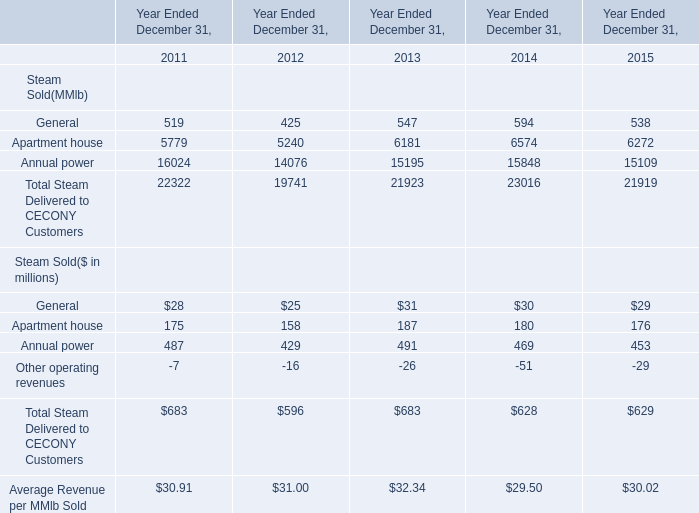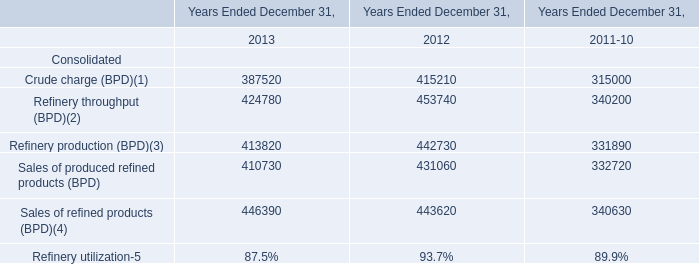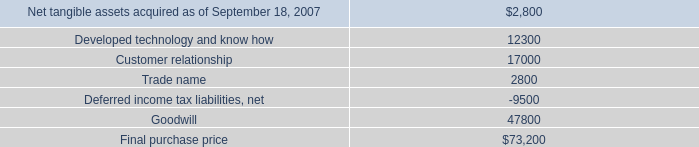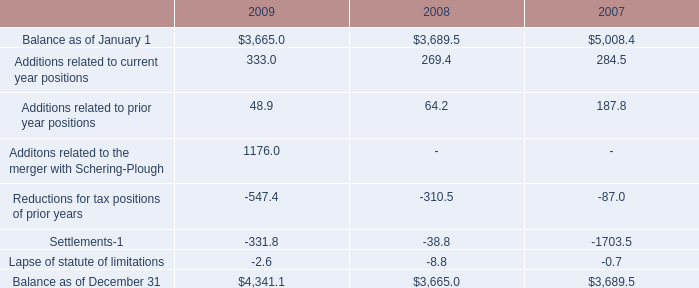What is the sum of elements for Total Steam Delivered to CECONY Customers in 2011 ? 
Computations: ((519 + 5779) + 16024)
Answer: 22322.0. 